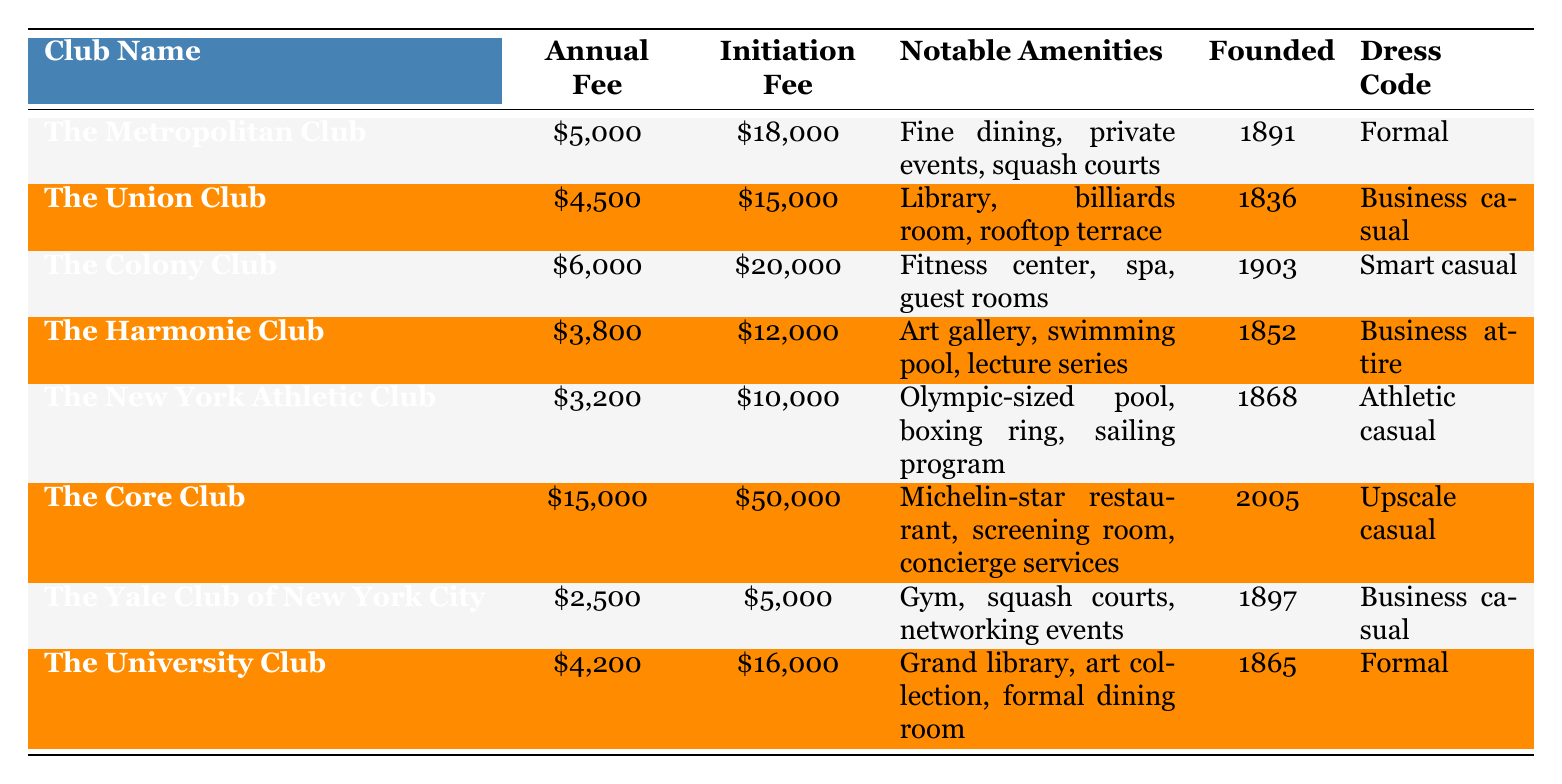What is the annual membership fee for The Yale Club of New York City? The table lists the annual membership fee for The Yale Club of New York City as $2,500.
Answer: $2,500 What notable amenities does The Core Club offer? According to the table, The Core Club offers a Michelin-star restaurant, screening room, and concierge services as notable amenities.
Answer: Michelin-star restaurant, screening room, concierge services Which club has the highest initiation fee? By checking the initiation fees listed in the table, The Core Club has an initiation fee of $50,000, which is the highest among all listed clubs.
Answer: The Core Club Is there a club founded in the year 1900 or later? The Colony Club was founded in 1903, which is after the year 1900, confirming that there is at least one club with that criterion.
Answer: Yes What is the total of the annual membership fees for The Union Club and The Yale Club of New York City? The annual membership fees for The Union Club ($4,500) and The Yale Club of New York City ($2,500) sum to $7,000 ($4,500 + $2,500 = $7,000).
Answer: $7,000 Which clubs have a formal dress code? The Metropolitan Club and The University Club both have a formal dress code according to the table.
Answer: The Metropolitan Club, The University Club What is the difference between the initiation fee of The Colony Club and The Harmonie Club? The initiation fee for The Colony Club is $20,000, and for The Harmonie Club, it is $12,000. The difference is $8,000 ($20,000 - $12,000 = $8,000).
Answer: $8,000 How many clubs offer a fitness facility or gym? The Colony Club and The Yale Club of New York City both provide fitness facilities (a fitness center and gym respectively), making a total of 2 clubs that offer such amenities.
Answer: 2 clubs What is the average annual membership fee for all clubs listed in the table? The total annual membership fees for the clubs are $5,000 + $4,500 + $6,000 + $3,800 + $3,200 + $15,000 + $2,500 + $4,200 = $44,200, and with 8 clubs this gives an average of $5,525 ($44,200 / 8 = $5,525).
Answer: $5,525 Which club has lower annual fees: The New York Athletic Club or The Harmonie Club? The annual fee for The New York Athletic Club is $3,200, while The Harmonie Club's fee is $3,800. Therefore, The New York Athletic Club has lower fees.
Answer: The New York Athletic Club 